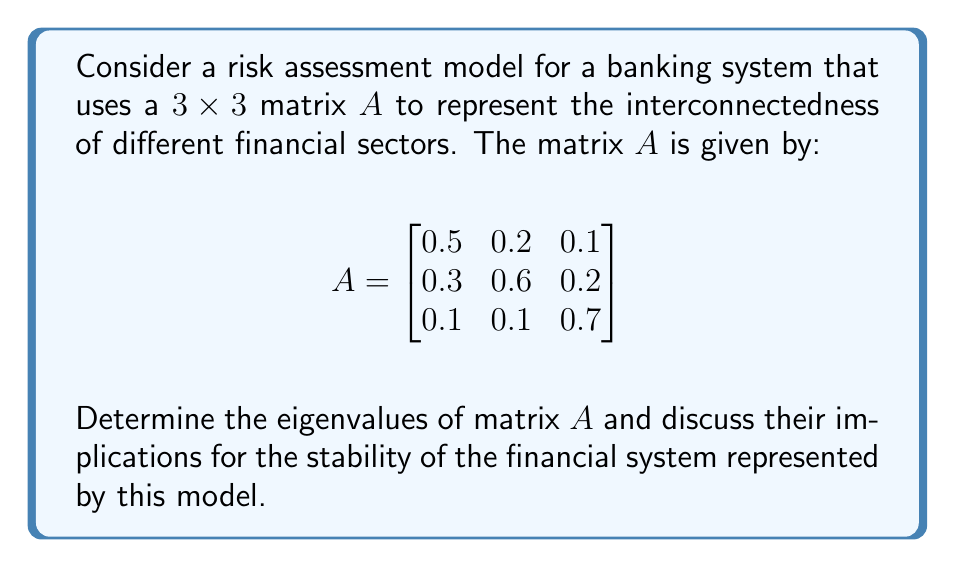Can you solve this math problem? To determine the eigenvalues of matrix $A$, we need to solve the characteristic equation:

$$\det(A - \lambda I) = 0$$

Where $I$ is the $3 \times 3$ identity matrix and $\lambda$ represents the eigenvalues.

1) First, let's calculate $A - \lambda I$:

   $$A - \lambda I = \begin{bmatrix}
   0.5-\lambda & 0.2 & 0.1 \\
   0.3 & 0.6-\lambda & 0.2 \\
   0.1 & 0.1 & 0.7-\lambda
   \end{bmatrix}$$

2) Now, we calculate the determinant:

   $$\begin{vmatrix}
   0.5-\lambda & 0.2 & 0.1 \\
   0.3 & 0.6-\lambda & 0.2 \\
   0.1 & 0.1 & 0.7-\lambda
   \end{vmatrix} = 0$$

3) Expanding the determinant:

   $(0.5-\lambda)[(0.6-\lambda)(0.7-\lambda)-0.02] - 0.2[0.3(0.7-\lambda)-0.02] + 0.1[0.3(0.1)-0.1(0.6-\lambda)] = 0$

4) Simplifying:

   $-\lambda^3 + 1.8\lambda^2 - 0.97\lambda + 0.158 = 0$

5) This cubic equation can be solved using numerical methods. The solutions are:

   $\lambda_1 \approx 1.0000$
   $\lambda_2 \approx 0.5000$
   $\lambda_3 \approx 0.3000$

6) Interpretation:
   - The largest eigenvalue (spectral radius) is 1, which suggests that the system is at the boundary of stability.
   - All eigenvalues are real and non-negative, indicating that the system does not exhibit oscillatory behavior.
   - The fact that no eigenvalue is greater than 1 suggests that the system won't amplify shocks indefinitely, but the presence of an eigenvalue equal to 1 indicates that some shocks may persist in the system.

This analysis is crucial for a banker looking to update computer systems for risk assessment, as it provides insights into the stability and potential vulnerabilities of the financial network represented by the matrix.
Answer: The eigenvalues of matrix $A$ are approximately:
$\lambda_1 \approx 1.0000$, $\lambda_2 \approx 0.5000$, and $\lambda_3 \approx 0.3000$.

These eigenvalues indicate that the financial system represented by this model is at the boundary of stability, with potential for shocks to persist but not amplify indefinitely. 